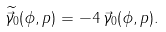<formula> <loc_0><loc_0><loc_500><loc_500>\widetilde { \vec { \gamma } _ { 0 } } ( \phi , p ) = - 4 \, \vec { \gamma } _ { 0 } ( \phi , p ) .</formula> 